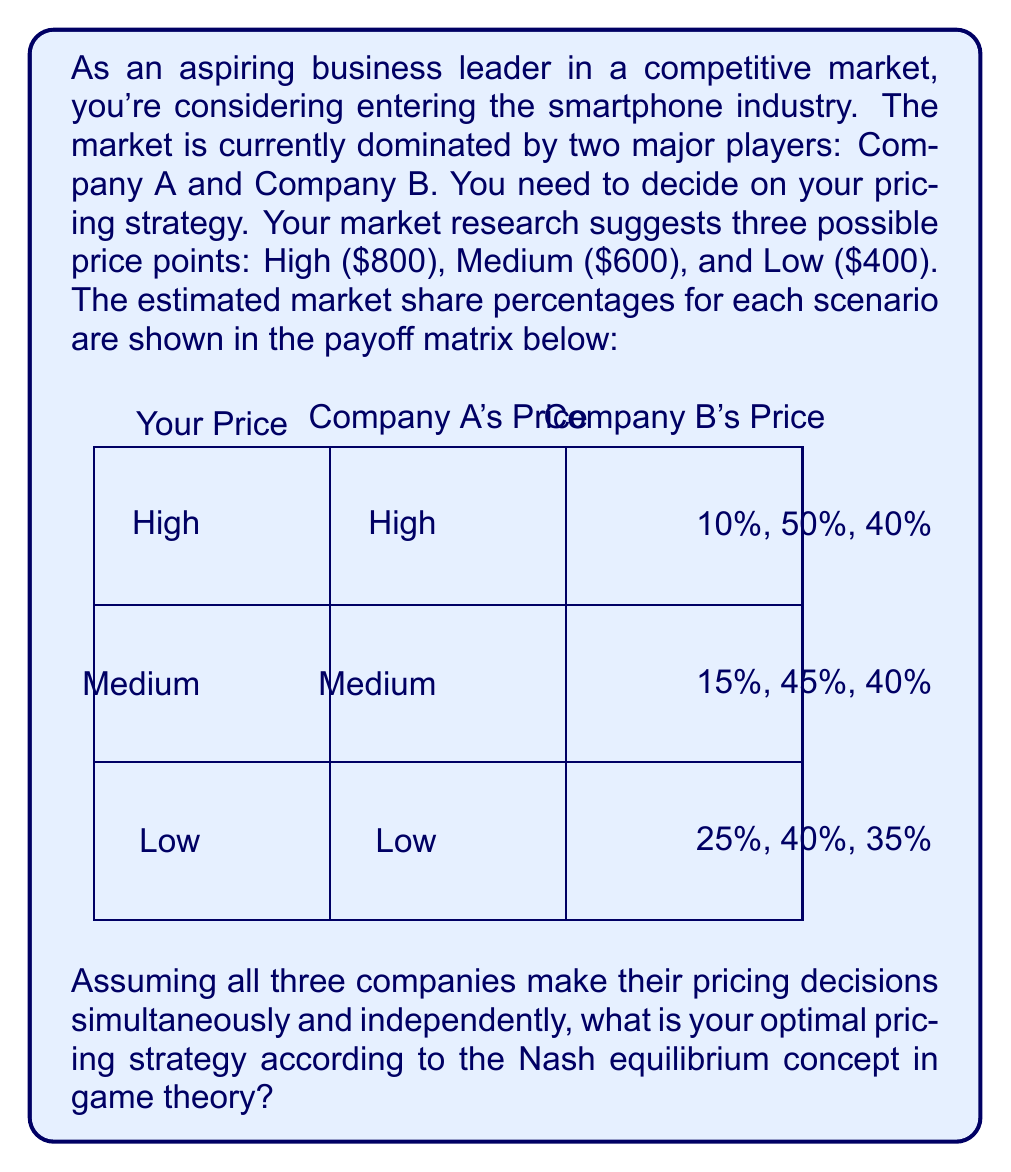Can you solve this math problem? To solve this problem, we need to analyze the payoff matrix using the Nash equilibrium concept. A Nash equilibrium occurs when no player can unilaterally change their strategy to increase their payoff.

Step 1: Identify the best responses for each player.

For your company:
- If both A and B choose High: Low is best (25% > 15% > 10%)
- If both A and B choose Medium: Low is best (25% > 15% > 10%)
- If both A and B choose Low: Low is best (25% > 15% > 10%)

For Company A and B, their strategies are fixed in this scenario, so we don't need to calculate their best responses.

Step 2: Find the Nash equilibrium.

Since Low is your best response regardless of what the other companies do, and the other companies' strategies are fixed, the Nash equilibrium is for you to choose the Low price strategy.

Step 3: Interpret the result.

The Nash equilibrium suggests that your optimal pricing strategy is to enter the market with a Low price of $400. This strategy gives you the highest market share (25%) regardless of the pricing decisions of Companies A and B.

This outcome aligns with a common market entry strategy called "penetration pricing," where a new entrant offers lower prices to gain market share quickly. However, it's important to note that this analysis doesn't consider factors such as production costs, long-term profitability, or potential reactions from competitors beyond this single decision point.
Answer: Low price ($400) 